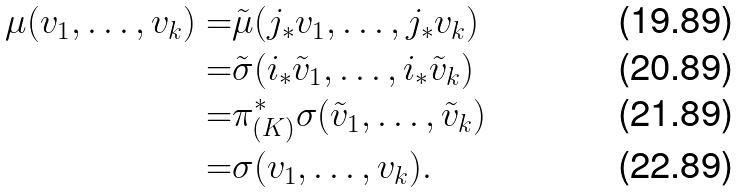Convert formula to latex. <formula><loc_0><loc_0><loc_500><loc_500>\mu ( v _ { 1 } , \dots , v _ { k } ) = & \tilde { \mu } ( j _ { * } v _ { 1 } , \dots , j _ { * } v _ { k } ) \\ = & \tilde { \sigma } ( i _ { * } \tilde { v } _ { 1 } , \dots , i _ { * } \tilde { v } _ { k } ) \\ = & \pi _ { ( K ) } ^ { * } \sigma ( \tilde { v } _ { 1 } , \dots , \tilde { v } _ { k } ) \\ = & \sigma ( v _ { 1 } , \dots , v _ { k } ) .</formula> 